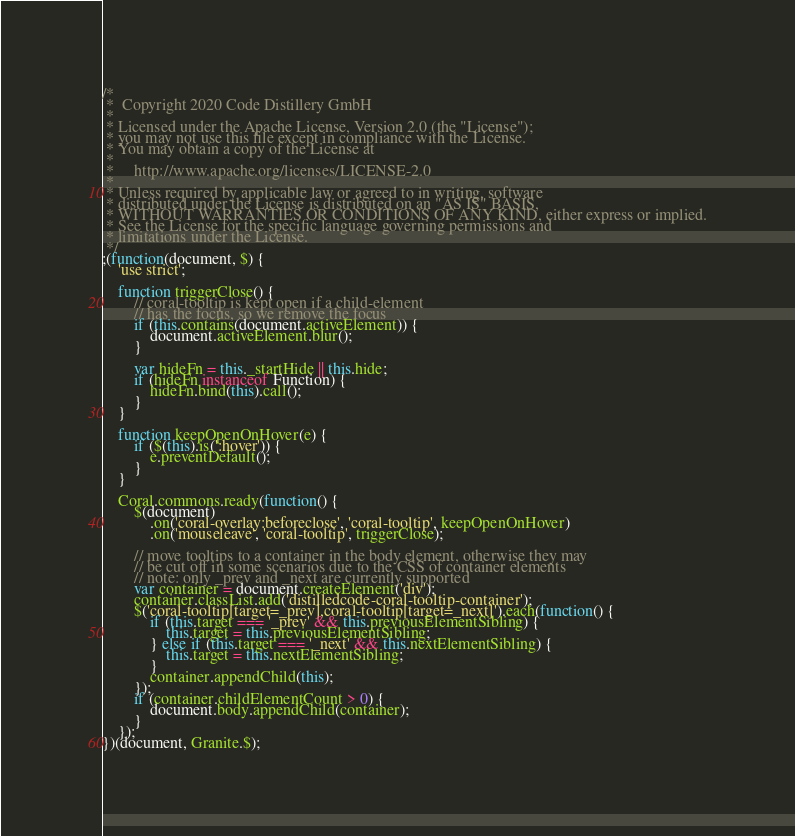<code> <loc_0><loc_0><loc_500><loc_500><_JavaScript_>/*
 *  Copyright 2020 Code Distillery GmbH
 *
 * Licensed under the Apache License, Version 2.0 (the "License");
 * you may not use this file except in compliance with the License.
 * You may obtain a copy of the License at
 *
 *     http://www.apache.org/licenses/LICENSE-2.0
 *
 * Unless required by applicable law or agreed to in writing, software
 * distributed under the License is distributed on an "AS IS" BASIS,
 * WITHOUT WARRANTIES OR CONDITIONS OF ANY KIND, either express or implied.
 * See the License for the specific language governing permissions and
 * limitations under the License.
 */
;(function(document, $) {
    'use strict';

    function triggerClose() {
        // coral-tooltip is kept open if a child-element
        // has the focus, so we remove the focus
        if (this.contains(document.activeElement)) {
            document.activeElement.blur();
        }

        var hideFn = this._startHide || this.hide;
        if (hideFn instanceof Function) {
            hideFn.bind(this).call();
        }
    }

    function keepOpenOnHover(e) {
        if ($(this).is(':hover')) {
            e.preventDefault();
        }
    }

    Coral.commons.ready(function() {
        $(document)
            .on('coral-overlay:beforeclose', 'coral-tooltip', keepOpenOnHover)
            .on('mouseleave', 'coral-tooltip', triggerClose);

        // move tooltips to a container in the body element, otherwise they may
        // be cut off in some scenarios due to the CSS of container elements
        // note: only _prev and _next are currently supported
        var container = document.createElement('div');
        container.classList.add('distilledcode-coral-tooltip-container');
        $('coral-tooltip[target=_prev],coral-tooltip[target=_next]').each(function() {
            if (this.target === '_prev' && this.previousElementSibling) {
                this.target = this.previousElementSibling;
            } else if (this.target === '_next' && this.nextElementSibling) {
                this.target = this.nextElementSibling;
            }
            container.appendChild(this);
        });
        if (container.childElementCount > 0) {
            document.body.appendChild(container);
        }
    });
})(document, Granite.$);
</code> 